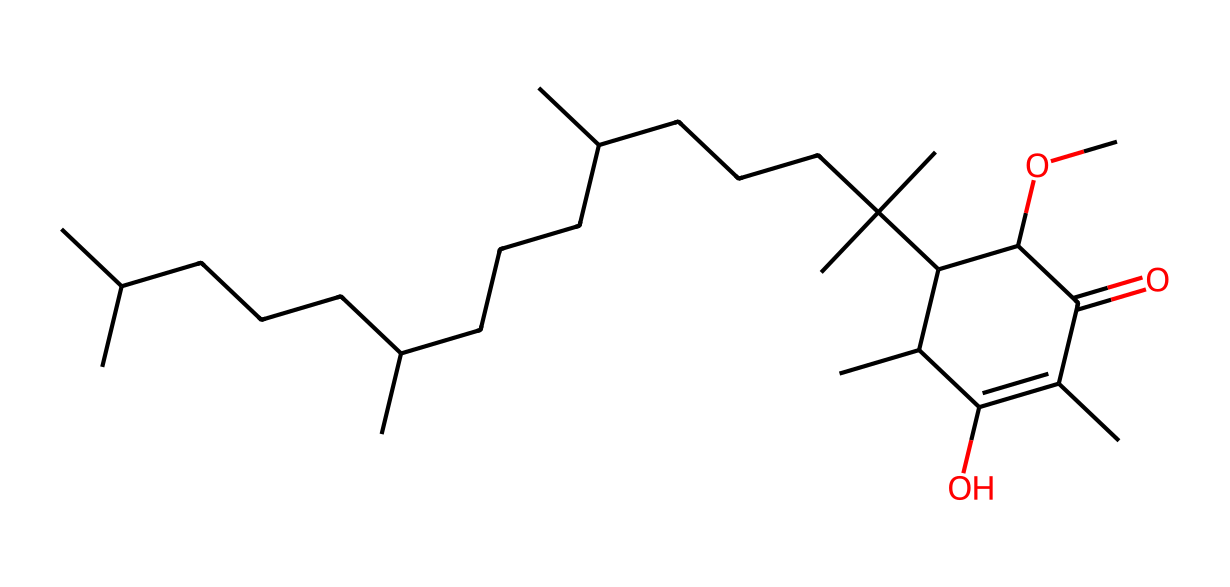What is the primary functional group present in vitamin E? The primary functional group in the SMILES representation is an alcohol (-OH) as indicated by the presence of "O" directly connected to a carbon atom with hydrogens.
Answer: alcohol How many carbons are in the vitamin E structure? By counting the carbon ('C') atoms in the SMILES representation, there are a total of 30 carbon atoms present in the structure.
Answer: 30 What is the total number of oxygen atoms in this chemical structure? In the given SMILES, there are three oxygen 'O' atoms represented, indicating the presence of functional groups such as an ether and a carbonyl.
Answer: 3 Which type of antioxidant does this structure represent? This chemical, known as tocopherol, is a type of fat-soluble antioxidant primarily recognized for its role in protecting cell membranes from oxidative damage.
Answer: tocopherol Does the structure of vitamin E contain any rings? Observing the representation, there is a cyclic structure present as indicated by "C1" which denotes the start of a ring, confirming the existence of a cyclic moiety.
Answer: yes How many double bonds are present in the vitamin E structure? In the SMILES notation, the '=' sign indicates double bonds, and careful examination reveals there are two double bonds in the carbon backbone of the structure.
Answer: 2 What health benefit is most commonly associated with vitamin E due to its structure? The structure of vitamin E, particularly with its antioxidant properties, is associated primarily with reducing oxidative stress in cells which helps in skin health and anti-aging.
Answer: reducing oxidative stress 